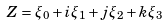Convert formula to latex. <formula><loc_0><loc_0><loc_500><loc_500>Z = \xi _ { 0 } + i \xi _ { 1 } + j \xi _ { 2 } + k \xi _ { 3 }</formula> 